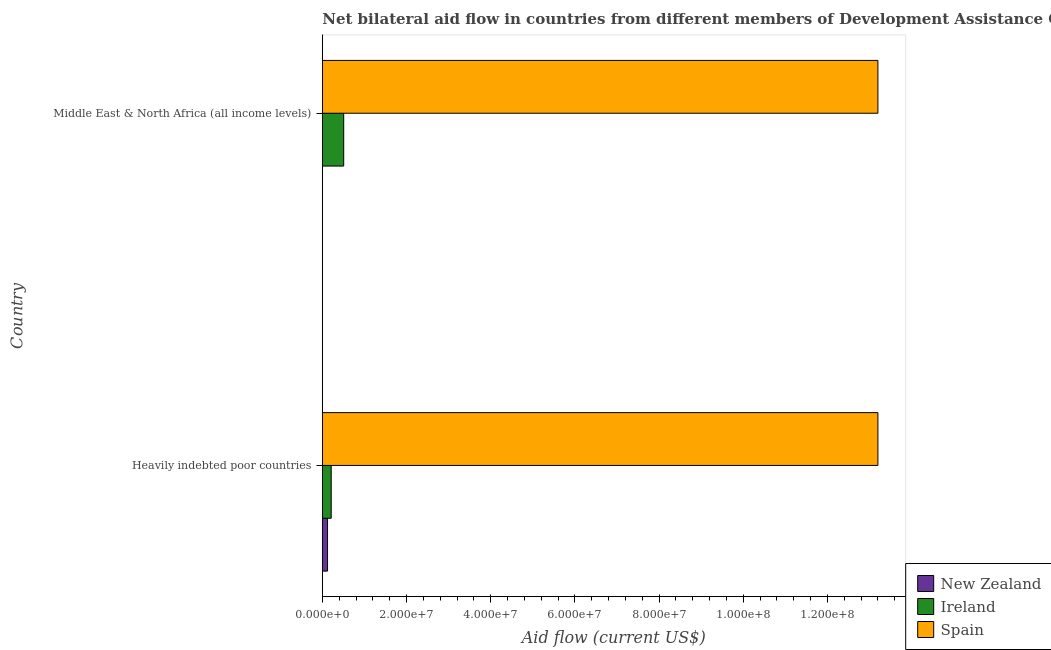How many different coloured bars are there?
Provide a short and direct response. 3. How many groups of bars are there?
Your response must be concise. 2. Are the number of bars on each tick of the Y-axis equal?
Offer a very short reply. Yes. What is the label of the 2nd group of bars from the top?
Offer a terse response. Heavily indebted poor countries. What is the amount of aid provided by spain in Middle East & North Africa (all income levels)?
Provide a short and direct response. 1.32e+08. Across all countries, what is the maximum amount of aid provided by new zealand?
Your answer should be very brief. 1.24e+06. Across all countries, what is the minimum amount of aid provided by spain?
Keep it short and to the point. 1.32e+08. In which country was the amount of aid provided by ireland maximum?
Provide a succinct answer. Middle East & North Africa (all income levels). In which country was the amount of aid provided by ireland minimum?
Your answer should be very brief. Heavily indebted poor countries. What is the total amount of aid provided by spain in the graph?
Your answer should be very brief. 2.64e+08. What is the difference between the amount of aid provided by spain in Heavily indebted poor countries and that in Middle East & North Africa (all income levels)?
Ensure brevity in your answer.  0. What is the difference between the amount of aid provided by spain in Heavily indebted poor countries and the amount of aid provided by ireland in Middle East & North Africa (all income levels)?
Your response must be concise. 1.27e+08. What is the average amount of aid provided by ireland per country?
Your answer should be compact. 3.60e+06. What is the difference between the amount of aid provided by new zealand and amount of aid provided by spain in Middle East & North Africa (all income levels)?
Your answer should be compact. -1.32e+08. In how many countries, is the amount of aid provided by ireland greater than 72000000 US$?
Ensure brevity in your answer.  0. In how many countries, is the amount of aid provided by spain greater than the average amount of aid provided by spain taken over all countries?
Provide a succinct answer. 0. What does the 1st bar from the bottom in Middle East & North Africa (all income levels) represents?
Provide a succinct answer. New Zealand. Is it the case that in every country, the sum of the amount of aid provided by new zealand and amount of aid provided by ireland is greater than the amount of aid provided by spain?
Provide a short and direct response. No. How many bars are there?
Give a very brief answer. 6. Are all the bars in the graph horizontal?
Give a very brief answer. Yes. How many countries are there in the graph?
Give a very brief answer. 2. What is the difference between two consecutive major ticks on the X-axis?
Keep it short and to the point. 2.00e+07. Are the values on the major ticks of X-axis written in scientific E-notation?
Make the answer very short. Yes. Does the graph contain any zero values?
Your answer should be very brief. No. Where does the legend appear in the graph?
Your answer should be very brief. Bottom right. How are the legend labels stacked?
Provide a short and direct response. Vertical. What is the title of the graph?
Offer a very short reply. Net bilateral aid flow in countries from different members of Development Assistance Committee. What is the label or title of the Y-axis?
Give a very brief answer. Country. What is the Aid flow (current US$) of New Zealand in Heavily indebted poor countries?
Your response must be concise. 1.24e+06. What is the Aid flow (current US$) in Ireland in Heavily indebted poor countries?
Your response must be concise. 2.11e+06. What is the Aid flow (current US$) in Spain in Heavily indebted poor countries?
Keep it short and to the point. 1.32e+08. What is the Aid flow (current US$) of Ireland in Middle East & North Africa (all income levels)?
Give a very brief answer. 5.08e+06. What is the Aid flow (current US$) of Spain in Middle East & North Africa (all income levels)?
Offer a terse response. 1.32e+08. Across all countries, what is the maximum Aid flow (current US$) of New Zealand?
Keep it short and to the point. 1.24e+06. Across all countries, what is the maximum Aid flow (current US$) in Ireland?
Offer a terse response. 5.08e+06. Across all countries, what is the maximum Aid flow (current US$) in Spain?
Your answer should be very brief. 1.32e+08. Across all countries, what is the minimum Aid flow (current US$) of New Zealand?
Offer a terse response. 10000. Across all countries, what is the minimum Aid flow (current US$) in Ireland?
Your answer should be very brief. 2.11e+06. Across all countries, what is the minimum Aid flow (current US$) of Spain?
Make the answer very short. 1.32e+08. What is the total Aid flow (current US$) of New Zealand in the graph?
Provide a succinct answer. 1.25e+06. What is the total Aid flow (current US$) in Ireland in the graph?
Provide a succinct answer. 7.19e+06. What is the total Aid flow (current US$) of Spain in the graph?
Your answer should be compact. 2.64e+08. What is the difference between the Aid flow (current US$) of New Zealand in Heavily indebted poor countries and that in Middle East & North Africa (all income levels)?
Ensure brevity in your answer.  1.23e+06. What is the difference between the Aid flow (current US$) in Ireland in Heavily indebted poor countries and that in Middle East & North Africa (all income levels)?
Provide a short and direct response. -2.97e+06. What is the difference between the Aid flow (current US$) of Spain in Heavily indebted poor countries and that in Middle East & North Africa (all income levels)?
Provide a succinct answer. 0. What is the difference between the Aid flow (current US$) in New Zealand in Heavily indebted poor countries and the Aid flow (current US$) in Ireland in Middle East & North Africa (all income levels)?
Your response must be concise. -3.84e+06. What is the difference between the Aid flow (current US$) of New Zealand in Heavily indebted poor countries and the Aid flow (current US$) of Spain in Middle East & North Africa (all income levels)?
Provide a short and direct response. -1.31e+08. What is the difference between the Aid flow (current US$) in Ireland in Heavily indebted poor countries and the Aid flow (current US$) in Spain in Middle East & North Africa (all income levels)?
Make the answer very short. -1.30e+08. What is the average Aid flow (current US$) in New Zealand per country?
Give a very brief answer. 6.25e+05. What is the average Aid flow (current US$) of Ireland per country?
Offer a very short reply. 3.60e+06. What is the average Aid flow (current US$) of Spain per country?
Offer a terse response. 1.32e+08. What is the difference between the Aid flow (current US$) of New Zealand and Aid flow (current US$) of Ireland in Heavily indebted poor countries?
Provide a succinct answer. -8.70e+05. What is the difference between the Aid flow (current US$) in New Zealand and Aid flow (current US$) in Spain in Heavily indebted poor countries?
Keep it short and to the point. -1.31e+08. What is the difference between the Aid flow (current US$) in Ireland and Aid flow (current US$) in Spain in Heavily indebted poor countries?
Your answer should be very brief. -1.30e+08. What is the difference between the Aid flow (current US$) in New Zealand and Aid flow (current US$) in Ireland in Middle East & North Africa (all income levels)?
Offer a terse response. -5.07e+06. What is the difference between the Aid flow (current US$) of New Zealand and Aid flow (current US$) of Spain in Middle East & North Africa (all income levels)?
Your answer should be very brief. -1.32e+08. What is the difference between the Aid flow (current US$) in Ireland and Aid flow (current US$) in Spain in Middle East & North Africa (all income levels)?
Give a very brief answer. -1.27e+08. What is the ratio of the Aid flow (current US$) of New Zealand in Heavily indebted poor countries to that in Middle East & North Africa (all income levels)?
Offer a very short reply. 124. What is the ratio of the Aid flow (current US$) in Ireland in Heavily indebted poor countries to that in Middle East & North Africa (all income levels)?
Your response must be concise. 0.42. What is the difference between the highest and the second highest Aid flow (current US$) of New Zealand?
Give a very brief answer. 1.23e+06. What is the difference between the highest and the second highest Aid flow (current US$) in Ireland?
Offer a very short reply. 2.97e+06. What is the difference between the highest and the lowest Aid flow (current US$) of New Zealand?
Offer a terse response. 1.23e+06. What is the difference between the highest and the lowest Aid flow (current US$) of Ireland?
Keep it short and to the point. 2.97e+06. What is the difference between the highest and the lowest Aid flow (current US$) in Spain?
Keep it short and to the point. 0. 